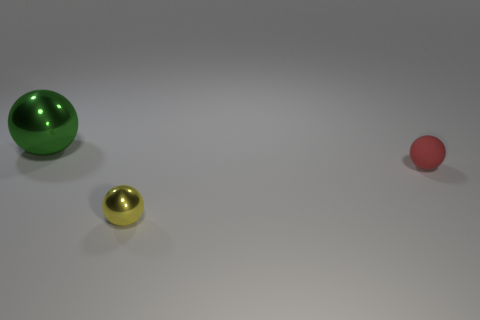Add 3 small yellow balls. How many objects exist? 6 Subtract all small yellow blocks. Subtract all green objects. How many objects are left? 2 Add 3 small yellow shiny objects. How many small yellow shiny objects are left? 4 Add 3 small gray rubber cylinders. How many small gray rubber cylinders exist? 3 Subtract 0 brown blocks. How many objects are left? 3 